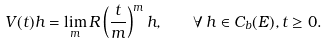<formula> <loc_0><loc_0><loc_500><loc_500>V ( t ) h = \lim _ { m } R \left ( \frac { t } { m } \right ) ^ { m } h , \quad \forall \, h \in C _ { b } ( E ) , t \geq 0 .</formula> 